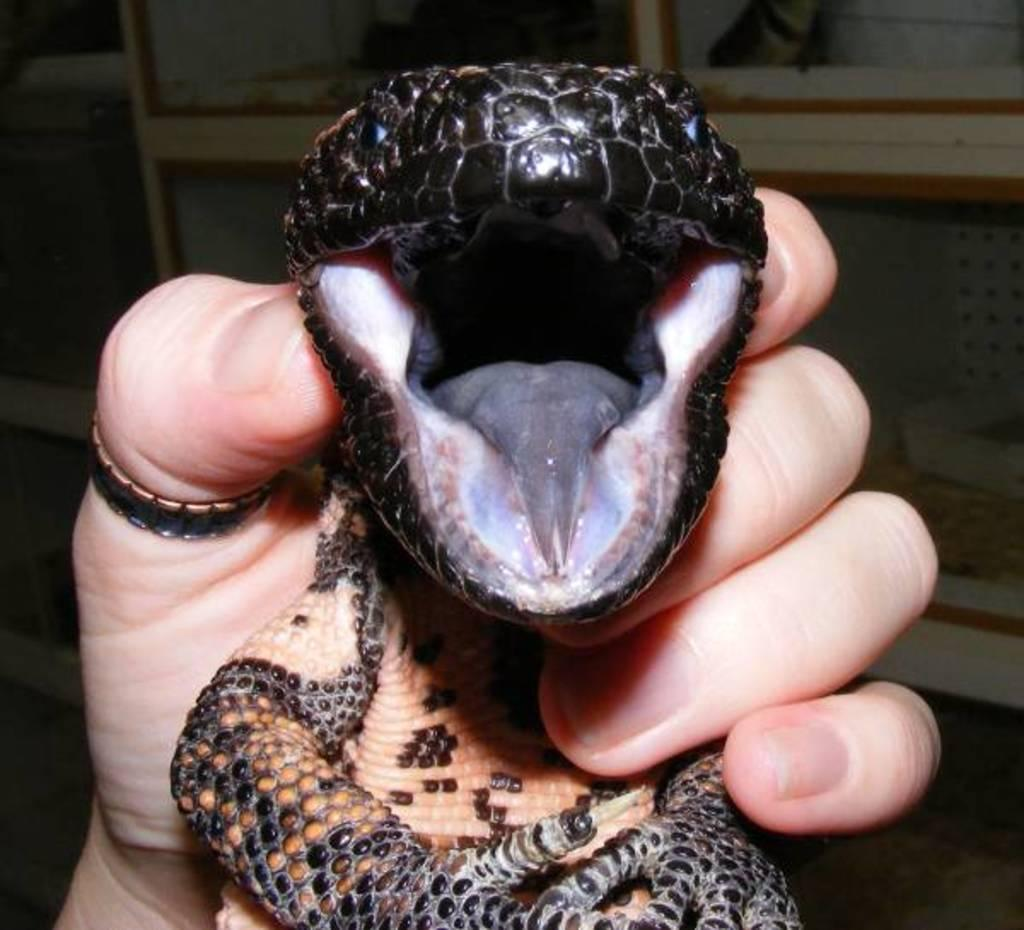What is the main subject of the image? There is a person in the image. What is the person holding in the image? The person is holding a reptile. What type of friction can be seen between the person's hand and the reptile in the image? There is no indication of friction between the person's hand and the reptile in the image. What type of steam is visible coming from the reptile in the image? There is no steam visible coming from the reptile in the image. 